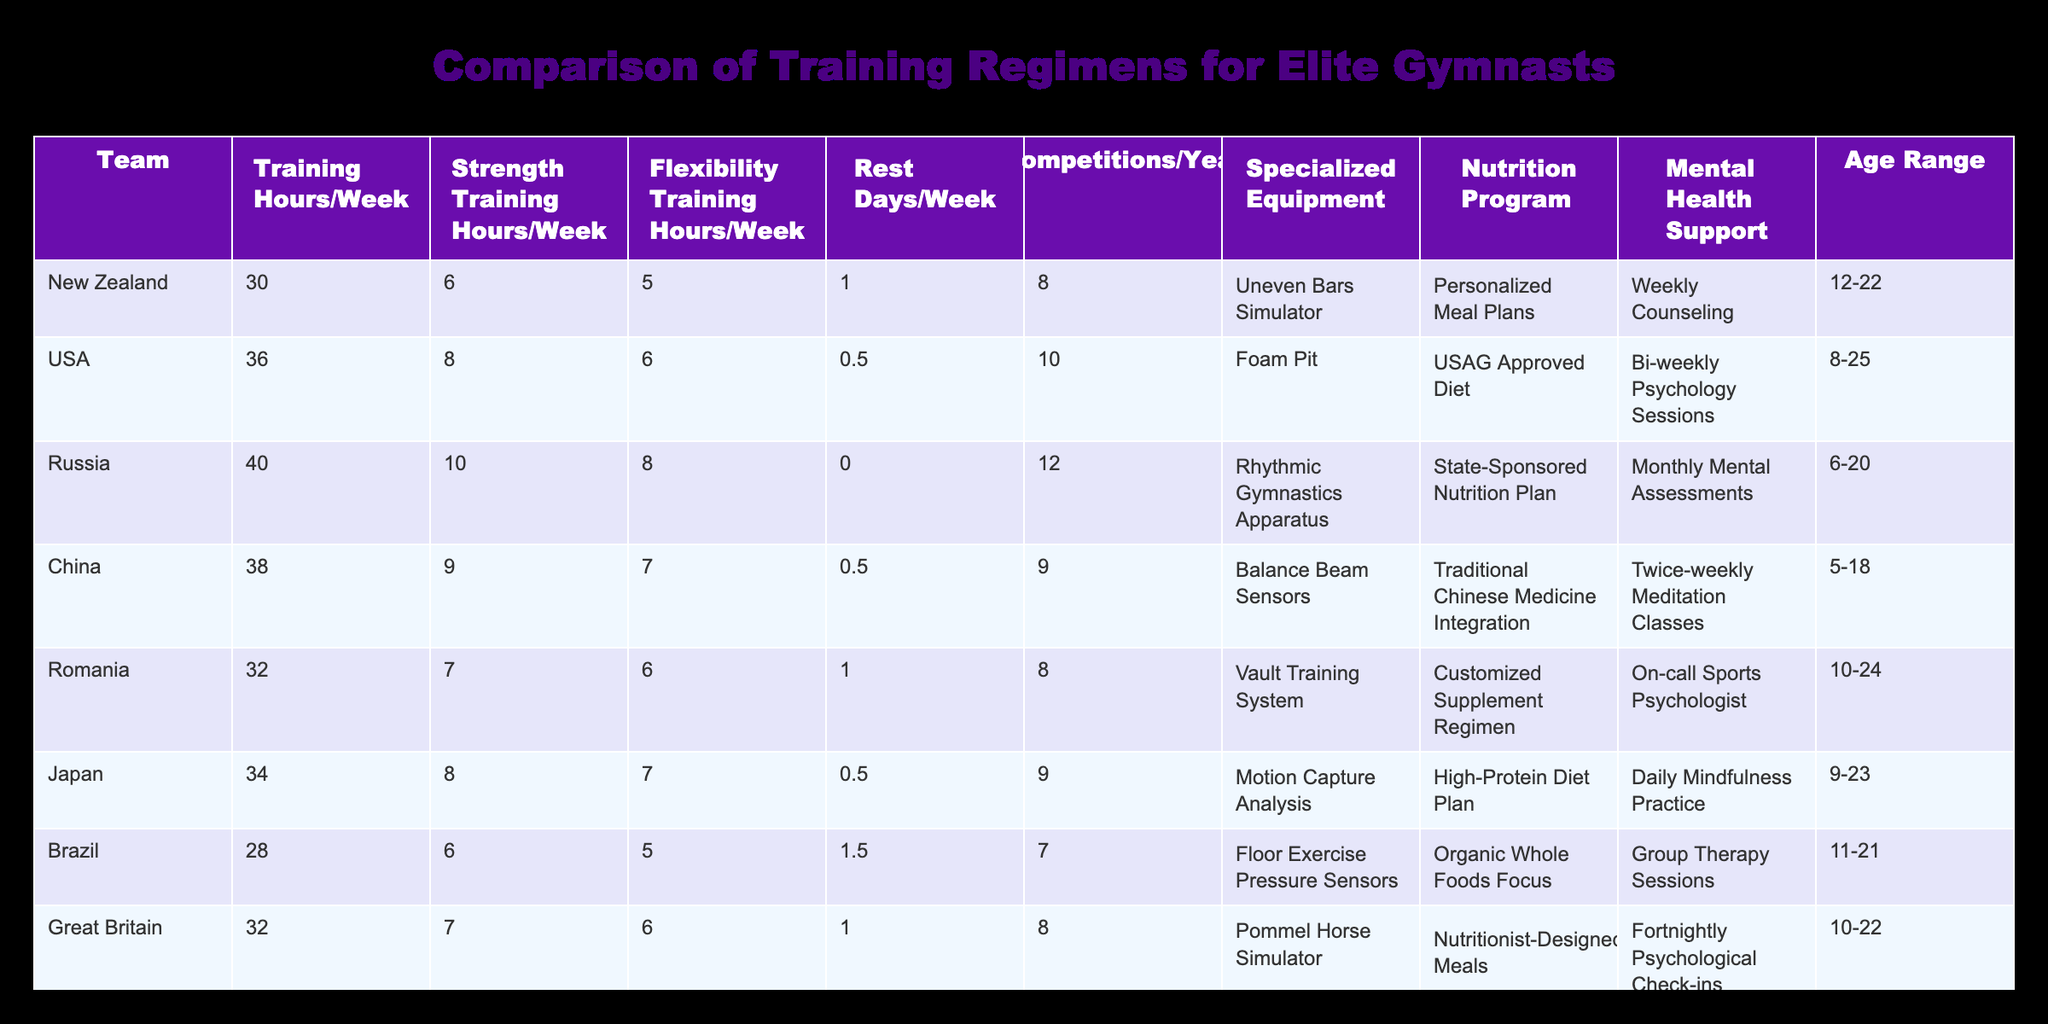What is the maximum number of Training Hours per Week among the teams? The table shows the Training Hours per Week for each team. Scanning through the values, we find New Zealand at 30, USA at 36, Russia at 40, China at 38, Romania at 32, Japan at 34, Brazil at 28, Great Britain at 32, and Australia at 30. The highest value here is 40 from Russia.
Answer: 40 Which team spends the least amount of time on Rest Days in a week, and what is the amount? Looking at the Rest Days per Week column, we see the following values: New Zealand with 1, USA with 0.5, Russia with 0, China with 0.5, Romania with 1, Japan with 0.5, Brazil with 1.5, Great Britain with 1, and Australia with 1. The lowest amount is 0 from Russia.
Answer: Russia (0) How many competitions does the USA participate in per year? According to the Competitions/Year column, the USA has a value of 10. This value is clearly stated in the row for the USA, which represents the number of competitions they participate in per year.
Answer: 10 How does the average Training Hours/Week for gymnasts from New Zealand, Japan, and Great Britain compare to that of Russia? First, calculate the average Training Hours for New Zealand (30), Japan (34), and Great Britain (32), which sums up to 30 + 34 + 32 = 96. Dividing by 3 gives us an average of 32. Now looking at Russia, their Training Hours/Week is 40. The comparison shows that 32 is less than 40.
Answer: Less than Is every team offering a Nutrition Program? Examining the Nutrition Program column, we see that all teams have some form of nutrition program. This can be verified by checking all entries for 'Personalized Meal Plans', 'USAG Approved Diet', 'State-Sponsored Nutrition Plan', 'Traditional Chinese Medicine Integration', 'Customized Supplement Regimen', 'High-Protein Diet Plan', 'Organic Whole Foods Focus', and 'Nutritionist-Designed Meals'. Therefore, all teams offer a program.
Answer: Yes What is the difference in Strength Training Hours/Week between the team with the most and least hours? First, identify the values for Strength Training Hours per week: New Zealand (6), USA (8), Russia (10), China (9), Romania (7), Japan (8), Brazil (6), Great Britain (7), and Australia (6). The maximum is 10 from Russia and the minimum is 6 from New Zealand, Brazil, and Australia. Calculating the difference gives us 10 - 6 = 4.
Answer: 4 Which country's gymnasts have the widest age range, and what is the range? Reviewing the Age Range column, we see the following ranges: New Zealand (12-22), USA (8-25), Russia (6-20), China (5-18), Romania (10-24), Japan (9-23), Brazil (11-21), Great Britain (10-22), and Australia (12-23). The country with the widest range is the USA, which has a range from 8 to 25, giving us a total range of 25 - 8 = 17.
Answer: USA (17) What percentage of teams provide Mental Health Support? There are a total of 9 teams listed. Looking through the Mental Health Support column, all teams (NZ, USA, Russia, China, Romania, Japan, Brazil, Great Britain, Australia) provide some form of mental health support. So the calculation would be (9/9) * 100% = 100%.
Answer: 100% 